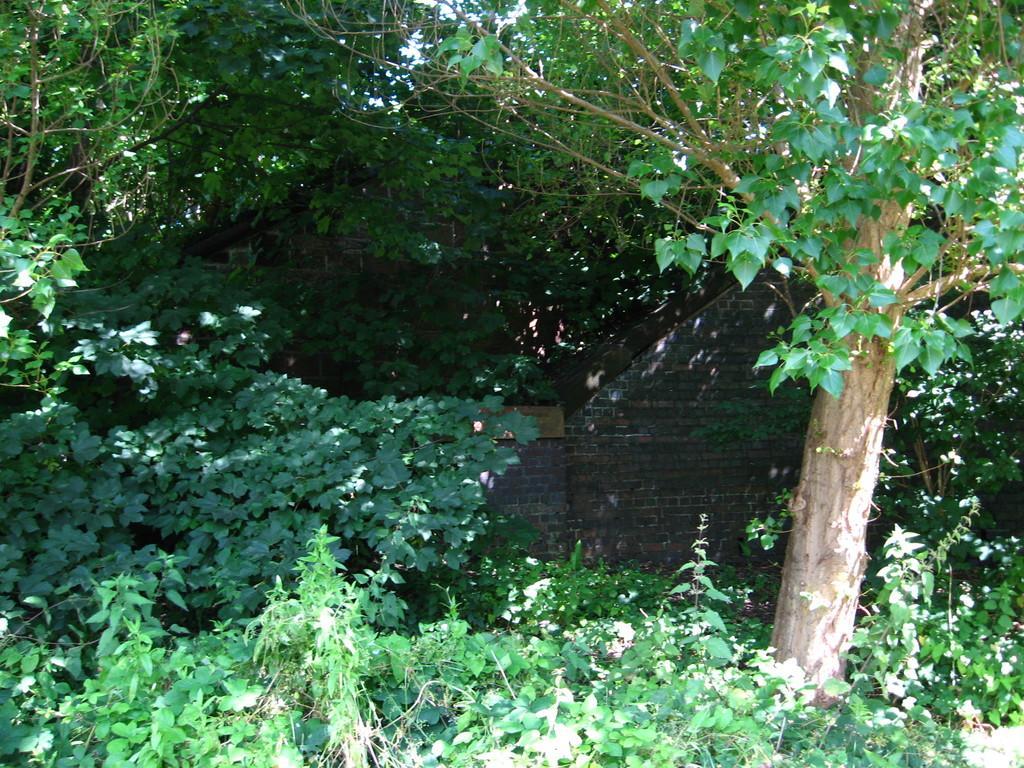How would you summarize this image in a sentence or two? There are a lot of trees and plants in an area and in between them a wall made up of bricks. 